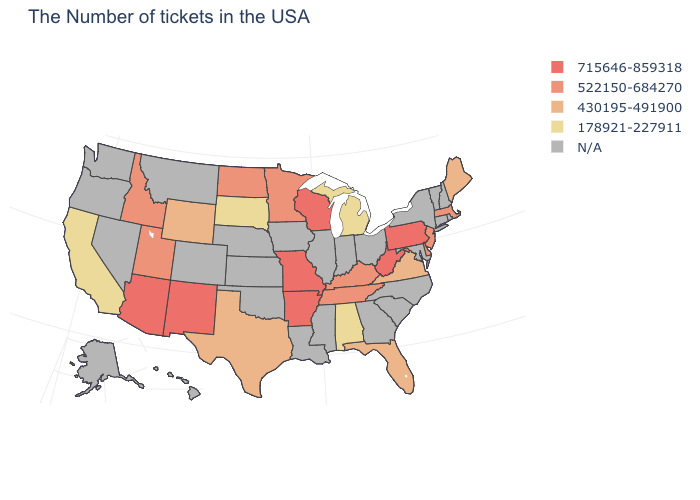What is the highest value in states that border Missouri?
Answer briefly. 715646-859318. What is the value of Rhode Island?
Concise answer only. N/A. Which states have the lowest value in the USA?
Quick response, please. Michigan, Alabama, South Dakota, California. Does the map have missing data?
Be succinct. Yes. What is the value of Montana?
Short answer required. N/A. Name the states that have a value in the range N/A?
Short answer required. Rhode Island, New Hampshire, Vermont, Connecticut, New York, Maryland, North Carolina, South Carolina, Ohio, Georgia, Indiana, Illinois, Mississippi, Louisiana, Iowa, Kansas, Nebraska, Oklahoma, Colorado, Montana, Nevada, Washington, Oregon, Alaska, Hawaii. Does New Jersey have the highest value in the USA?
Short answer required. No. Does Maine have the lowest value in the Northeast?
Be succinct. Yes. What is the lowest value in states that border Mississippi?
Give a very brief answer. 178921-227911. Name the states that have a value in the range 715646-859318?
Answer briefly. Pennsylvania, West Virginia, Wisconsin, Missouri, Arkansas, New Mexico, Arizona. Which states have the lowest value in the USA?
Answer briefly. Michigan, Alabama, South Dakota, California. Is the legend a continuous bar?
Keep it brief. No. What is the highest value in states that border Kentucky?
Quick response, please. 715646-859318. 